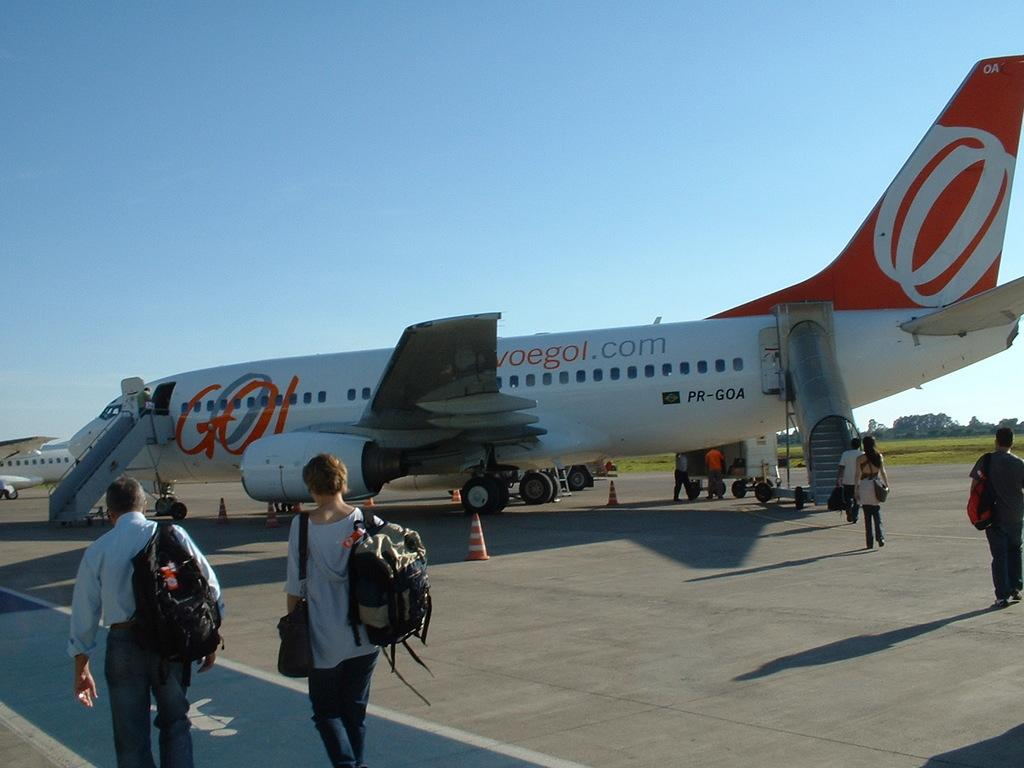<image>
Offer a succinct explanation of the picture presented. An orange and white passenger airplane sports a colorful "GO" between its wing and its door. 